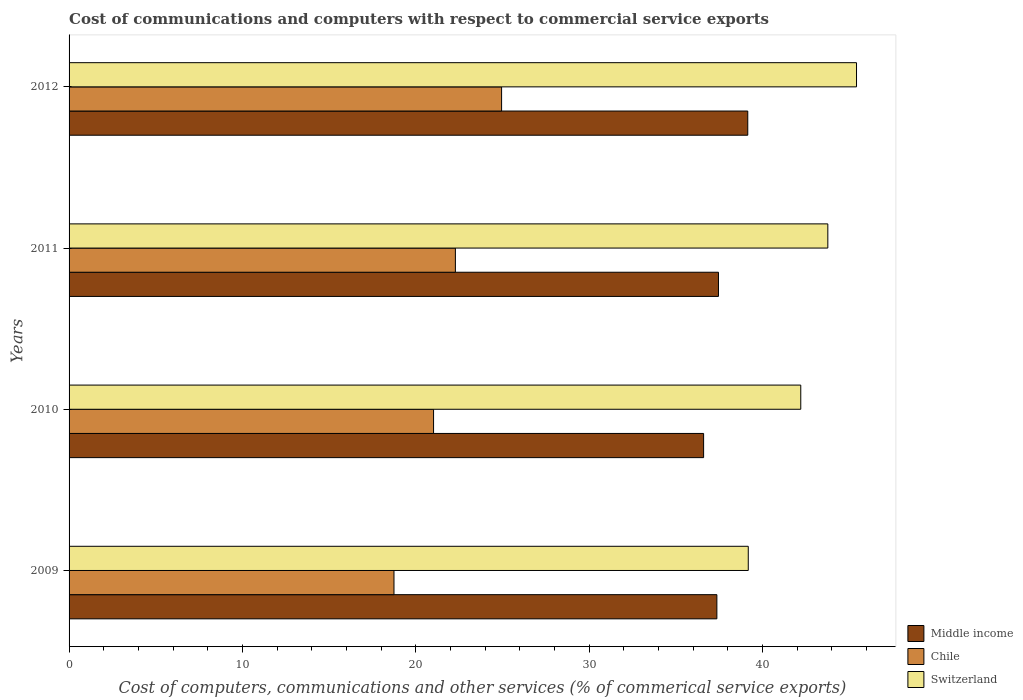How many groups of bars are there?
Your answer should be very brief. 4. Are the number of bars per tick equal to the number of legend labels?
Make the answer very short. Yes. Are the number of bars on each tick of the Y-axis equal?
Offer a very short reply. Yes. What is the label of the 2nd group of bars from the top?
Your answer should be very brief. 2011. In how many cases, is the number of bars for a given year not equal to the number of legend labels?
Make the answer very short. 0. What is the cost of communications and computers in Chile in 2010?
Offer a very short reply. 21.02. Across all years, what is the maximum cost of communications and computers in Chile?
Offer a very short reply. 24.95. Across all years, what is the minimum cost of communications and computers in Middle income?
Offer a terse response. 36.6. What is the total cost of communications and computers in Middle income in the graph?
Offer a terse response. 150.56. What is the difference between the cost of communications and computers in Chile in 2009 and that in 2012?
Your answer should be compact. -6.21. What is the difference between the cost of communications and computers in Switzerland in 2011 and the cost of communications and computers in Chile in 2012?
Make the answer very short. 18.82. What is the average cost of communications and computers in Chile per year?
Your answer should be compact. 21.75. In the year 2009, what is the difference between the cost of communications and computers in Chile and cost of communications and computers in Switzerland?
Ensure brevity in your answer.  -20.43. In how many years, is the cost of communications and computers in Switzerland greater than 44 %?
Offer a very short reply. 1. What is the ratio of the cost of communications and computers in Middle income in 2010 to that in 2012?
Your answer should be compact. 0.93. What is the difference between the highest and the second highest cost of communications and computers in Middle income?
Your answer should be compact. 1.69. What is the difference between the highest and the lowest cost of communications and computers in Switzerland?
Your answer should be compact. 6.24. What does the 2nd bar from the top in 2010 represents?
Your response must be concise. Chile. What does the 1st bar from the bottom in 2009 represents?
Give a very brief answer. Middle income. How many years are there in the graph?
Your response must be concise. 4. What is the difference between two consecutive major ticks on the X-axis?
Provide a succinct answer. 10. Does the graph contain grids?
Ensure brevity in your answer.  No. How many legend labels are there?
Ensure brevity in your answer.  3. How are the legend labels stacked?
Provide a succinct answer. Vertical. What is the title of the graph?
Your answer should be compact. Cost of communications and computers with respect to commercial service exports. Does "Estonia" appear as one of the legend labels in the graph?
Your answer should be very brief. No. What is the label or title of the X-axis?
Your answer should be compact. Cost of computers, communications and other services (% of commerical service exports). What is the label or title of the Y-axis?
Your answer should be very brief. Years. What is the Cost of computers, communications and other services (% of commerical service exports) in Middle income in 2009?
Give a very brief answer. 37.36. What is the Cost of computers, communications and other services (% of commerical service exports) in Chile in 2009?
Provide a short and direct response. 18.74. What is the Cost of computers, communications and other services (% of commerical service exports) of Switzerland in 2009?
Your response must be concise. 39.17. What is the Cost of computers, communications and other services (% of commerical service exports) of Middle income in 2010?
Your response must be concise. 36.6. What is the Cost of computers, communications and other services (% of commerical service exports) of Chile in 2010?
Offer a terse response. 21.02. What is the Cost of computers, communications and other services (% of commerical service exports) in Switzerland in 2010?
Your answer should be very brief. 42.2. What is the Cost of computers, communications and other services (% of commerical service exports) in Middle income in 2011?
Make the answer very short. 37.45. What is the Cost of computers, communications and other services (% of commerical service exports) in Chile in 2011?
Your answer should be very brief. 22.28. What is the Cost of computers, communications and other services (% of commerical service exports) of Switzerland in 2011?
Provide a short and direct response. 43.76. What is the Cost of computers, communications and other services (% of commerical service exports) of Middle income in 2012?
Offer a very short reply. 39.14. What is the Cost of computers, communications and other services (% of commerical service exports) of Chile in 2012?
Provide a succinct answer. 24.95. What is the Cost of computers, communications and other services (% of commerical service exports) of Switzerland in 2012?
Your response must be concise. 45.42. Across all years, what is the maximum Cost of computers, communications and other services (% of commerical service exports) of Middle income?
Keep it short and to the point. 39.14. Across all years, what is the maximum Cost of computers, communications and other services (% of commerical service exports) of Chile?
Your answer should be compact. 24.95. Across all years, what is the maximum Cost of computers, communications and other services (% of commerical service exports) in Switzerland?
Keep it short and to the point. 45.42. Across all years, what is the minimum Cost of computers, communications and other services (% of commerical service exports) in Middle income?
Ensure brevity in your answer.  36.6. Across all years, what is the minimum Cost of computers, communications and other services (% of commerical service exports) of Chile?
Your answer should be compact. 18.74. Across all years, what is the minimum Cost of computers, communications and other services (% of commerical service exports) of Switzerland?
Provide a short and direct response. 39.17. What is the total Cost of computers, communications and other services (% of commerical service exports) of Middle income in the graph?
Your answer should be compact. 150.56. What is the total Cost of computers, communications and other services (% of commerical service exports) of Chile in the graph?
Your answer should be compact. 86.99. What is the total Cost of computers, communications and other services (% of commerical service exports) in Switzerland in the graph?
Your response must be concise. 170.55. What is the difference between the Cost of computers, communications and other services (% of commerical service exports) of Middle income in 2009 and that in 2010?
Your response must be concise. 0.76. What is the difference between the Cost of computers, communications and other services (% of commerical service exports) in Chile in 2009 and that in 2010?
Offer a terse response. -2.28. What is the difference between the Cost of computers, communications and other services (% of commerical service exports) of Switzerland in 2009 and that in 2010?
Your answer should be very brief. -3.03. What is the difference between the Cost of computers, communications and other services (% of commerical service exports) of Middle income in 2009 and that in 2011?
Make the answer very short. -0.09. What is the difference between the Cost of computers, communications and other services (% of commerical service exports) in Chile in 2009 and that in 2011?
Your answer should be very brief. -3.54. What is the difference between the Cost of computers, communications and other services (% of commerical service exports) in Switzerland in 2009 and that in 2011?
Your response must be concise. -4.59. What is the difference between the Cost of computers, communications and other services (% of commerical service exports) in Middle income in 2009 and that in 2012?
Your response must be concise. -1.78. What is the difference between the Cost of computers, communications and other services (% of commerical service exports) of Chile in 2009 and that in 2012?
Provide a succinct answer. -6.21. What is the difference between the Cost of computers, communications and other services (% of commerical service exports) in Switzerland in 2009 and that in 2012?
Keep it short and to the point. -6.24. What is the difference between the Cost of computers, communications and other services (% of commerical service exports) in Middle income in 2010 and that in 2011?
Offer a terse response. -0.86. What is the difference between the Cost of computers, communications and other services (% of commerical service exports) of Chile in 2010 and that in 2011?
Your answer should be compact. -1.26. What is the difference between the Cost of computers, communications and other services (% of commerical service exports) of Switzerland in 2010 and that in 2011?
Your answer should be compact. -1.56. What is the difference between the Cost of computers, communications and other services (% of commerical service exports) in Middle income in 2010 and that in 2012?
Ensure brevity in your answer.  -2.55. What is the difference between the Cost of computers, communications and other services (% of commerical service exports) in Chile in 2010 and that in 2012?
Your response must be concise. -3.92. What is the difference between the Cost of computers, communications and other services (% of commerical service exports) in Switzerland in 2010 and that in 2012?
Your answer should be compact. -3.22. What is the difference between the Cost of computers, communications and other services (% of commerical service exports) of Middle income in 2011 and that in 2012?
Your answer should be compact. -1.69. What is the difference between the Cost of computers, communications and other services (% of commerical service exports) of Chile in 2011 and that in 2012?
Keep it short and to the point. -2.66. What is the difference between the Cost of computers, communications and other services (% of commerical service exports) of Switzerland in 2011 and that in 2012?
Provide a short and direct response. -1.65. What is the difference between the Cost of computers, communications and other services (% of commerical service exports) in Middle income in 2009 and the Cost of computers, communications and other services (% of commerical service exports) in Chile in 2010?
Provide a succinct answer. 16.34. What is the difference between the Cost of computers, communications and other services (% of commerical service exports) in Middle income in 2009 and the Cost of computers, communications and other services (% of commerical service exports) in Switzerland in 2010?
Offer a terse response. -4.84. What is the difference between the Cost of computers, communications and other services (% of commerical service exports) of Chile in 2009 and the Cost of computers, communications and other services (% of commerical service exports) of Switzerland in 2010?
Your answer should be very brief. -23.46. What is the difference between the Cost of computers, communications and other services (% of commerical service exports) of Middle income in 2009 and the Cost of computers, communications and other services (% of commerical service exports) of Chile in 2011?
Give a very brief answer. 15.08. What is the difference between the Cost of computers, communications and other services (% of commerical service exports) of Middle income in 2009 and the Cost of computers, communications and other services (% of commerical service exports) of Switzerland in 2011?
Offer a terse response. -6.4. What is the difference between the Cost of computers, communications and other services (% of commerical service exports) in Chile in 2009 and the Cost of computers, communications and other services (% of commerical service exports) in Switzerland in 2011?
Provide a succinct answer. -25.02. What is the difference between the Cost of computers, communications and other services (% of commerical service exports) in Middle income in 2009 and the Cost of computers, communications and other services (% of commerical service exports) in Chile in 2012?
Offer a very short reply. 12.42. What is the difference between the Cost of computers, communications and other services (% of commerical service exports) in Middle income in 2009 and the Cost of computers, communications and other services (% of commerical service exports) in Switzerland in 2012?
Offer a terse response. -8.05. What is the difference between the Cost of computers, communications and other services (% of commerical service exports) of Chile in 2009 and the Cost of computers, communications and other services (% of commerical service exports) of Switzerland in 2012?
Ensure brevity in your answer.  -26.68. What is the difference between the Cost of computers, communications and other services (% of commerical service exports) in Middle income in 2010 and the Cost of computers, communications and other services (% of commerical service exports) in Chile in 2011?
Offer a very short reply. 14.32. What is the difference between the Cost of computers, communications and other services (% of commerical service exports) in Middle income in 2010 and the Cost of computers, communications and other services (% of commerical service exports) in Switzerland in 2011?
Keep it short and to the point. -7.16. What is the difference between the Cost of computers, communications and other services (% of commerical service exports) in Chile in 2010 and the Cost of computers, communications and other services (% of commerical service exports) in Switzerland in 2011?
Provide a succinct answer. -22.74. What is the difference between the Cost of computers, communications and other services (% of commerical service exports) in Middle income in 2010 and the Cost of computers, communications and other services (% of commerical service exports) in Chile in 2012?
Your response must be concise. 11.65. What is the difference between the Cost of computers, communications and other services (% of commerical service exports) in Middle income in 2010 and the Cost of computers, communications and other services (% of commerical service exports) in Switzerland in 2012?
Your response must be concise. -8.82. What is the difference between the Cost of computers, communications and other services (% of commerical service exports) of Chile in 2010 and the Cost of computers, communications and other services (% of commerical service exports) of Switzerland in 2012?
Keep it short and to the point. -24.39. What is the difference between the Cost of computers, communications and other services (% of commerical service exports) of Middle income in 2011 and the Cost of computers, communications and other services (% of commerical service exports) of Chile in 2012?
Offer a very short reply. 12.51. What is the difference between the Cost of computers, communications and other services (% of commerical service exports) of Middle income in 2011 and the Cost of computers, communications and other services (% of commerical service exports) of Switzerland in 2012?
Offer a very short reply. -7.96. What is the difference between the Cost of computers, communications and other services (% of commerical service exports) of Chile in 2011 and the Cost of computers, communications and other services (% of commerical service exports) of Switzerland in 2012?
Provide a succinct answer. -23.13. What is the average Cost of computers, communications and other services (% of commerical service exports) in Middle income per year?
Make the answer very short. 37.64. What is the average Cost of computers, communications and other services (% of commerical service exports) in Chile per year?
Provide a short and direct response. 21.75. What is the average Cost of computers, communications and other services (% of commerical service exports) of Switzerland per year?
Offer a terse response. 42.64. In the year 2009, what is the difference between the Cost of computers, communications and other services (% of commerical service exports) in Middle income and Cost of computers, communications and other services (% of commerical service exports) in Chile?
Provide a short and direct response. 18.62. In the year 2009, what is the difference between the Cost of computers, communications and other services (% of commerical service exports) of Middle income and Cost of computers, communications and other services (% of commerical service exports) of Switzerland?
Give a very brief answer. -1.81. In the year 2009, what is the difference between the Cost of computers, communications and other services (% of commerical service exports) in Chile and Cost of computers, communications and other services (% of commerical service exports) in Switzerland?
Your response must be concise. -20.43. In the year 2010, what is the difference between the Cost of computers, communications and other services (% of commerical service exports) of Middle income and Cost of computers, communications and other services (% of commerical service exports) of Chile?
Give a very brief answer. 15.58. In the year 2010, what is the difference between the Cost of computers, communications and other services (% of commerical service exports) of Middle income and Cost of computers, communications and other services (% of commerical service exports) of Switzerland?
Your response must be concise. -5.6. In the year 2010, what is the difference between the Cost of computers, communications and other services (% of commerical service exports) in Chile and Cost of computers, communications and other services (% of commerical service exports) in Switzerland?
Give a very brief answer. -21.18. In the year 2011, what is the difference between the Cost of computers, communications and other services (% of commerical service exports) in Middle income and Cost of computers, communications and other services (% of commerical service exports) in Chile?
Offer a terse response. 15.17. In the year 2011, what is the difference between the Cost of computers, communications and other services (% of commerical service exports) of Middle income and Cost of computers, communications and other services (% of commerical service exports) of Switzerland?
Your response must be concise. -6.31. In the year 2011, what is the difference between the Cost of computers, communications and other services (% of commerical service exports) in Chile and Cost of computers, communications and other services (% of commerical service exports) in Switzerland?
Give a very brief answer. -21.48. In the year 2012, what is the difference between the Cost of computers, communications and other services (% of commerical service exports) of Middle income and Cost of computers, communications and other services (% of commerical service exports) of Chile?
Provide a succinct answer. 14.2. In the year 2012, what is the difference between the Cost of computers, communications and other services (% of commerical service exports) of Middle income and Cost of computers, communications and other services (% of commerical service exports) of Switzerland?
Your answer should be very brief. -6.27. In the year 2012, what is the difference between the Cost of computers, communications and other services (% of commerical service exports) in Chile and Cost of computers, communications and other services (% of commerical service exports) in Switzerland?
Keep it short and to the point. -20.47. What is the ratio of the Cost of computers, communications and other services (% of commerical service exports) of Middle income in 2009 to that in 2010?
Offer a terse response. 1.02. What is the ratio of the Cost of computers, communications and other services (% of commerical service exports) of Chile in 2009 to that in 2010?
Provide a short and direct response. 0.89. What is the ratio of the Cost of computers, communications and other services (% of commerical service exports) of Switzerland in 2009 to that in 2010?
Give a very brief answer. 0.93. What is the ratio of the Cost of computers, communications and other services (% of commerical service exports) in Chile in 2009 to that in 2011?
Your answer should be very brief. 0.84. What is the ratio of the Cost of computers, communications and other services (% of commerical service exports) in Switzerland in 2009 to that in 2011?
Give a very brief answer. 0.9. What is the ratio of the Cost of computers, communications and other services (% of commerical service exports) of Middle income in 2009 to that in 2012?
Your response must be concise. 0.95. What is the ratio of the Cost of computers, communications and other services (% of commerical service exports) in Chile in 2009 to that in 2012?
Offer a terse response. 0.75. What is the ratio of the Cost of computers, communications and other services (% of commerical service exports) in Switzerland in 2009 to that in 2012?
Your answer should be compact. 0.86. What is the ratio of the Cost of computers, communications and other services (% of commerical service exports) of Middle income in 2010 to that in 2011?
Offer a terse response. 0.98. What is the ratio of the Cost of computers, communications and other services (% of commerical service exports) of Chile in 2010 to that in 2011?
Ensure brevity in your answer.  0.94. What is the ratio of the Cost of computers, communications and other services (% of commerical service exports) of Middle income in 2010 to that in 2012?
Offer a very short reply. 0.93. What is the ratio of the Cost of computers, communications and other services (% of commerical service exports) of Chile in 2010 to that in 2012?
Offer a terse response. 0.84. What is the ratio of the Cost of computers, communications and other services (% of commerical service exports) in Switzerland in 2010 to that in 2012?
Provide a short and direct response. 0.93. What is the ratio of the Cost of computers, communications and other services (% of commerical service exports) in Middle income in 2011 to that in 2012?
Your answer should be compact. 0.96. What is the ratio of the Cost of computers, communications and other services (% of commerical service exports) of Chile in 2011 to that in 2012?
Keep it short and to the point. 0.89. What is the ratio of the Cost of computers, communications and other services (% of commerical service exports) of Switzerland in 2011 to that in 2012?
Offer a very short reply. 0.96. What is the difference between the highest and the second highest Cost of computers, communications and other services (% of commerical service exports) of Middle income?
Ensure brevity in your answer.  1.69. What is the difference between the highest and the second highest Cost of computers, communications and other services (% of commerical service exports) in Chile?
Give a very brief answer. 2.66. What is the difference between the highest and the second highest Cost of computers, communications and other services (% of commerical service exports) in Switzerland?
Offer a terse response. 1.65. What is the difference between the highest and the lowest Cost of computers, communications and other services (% of commerical service exports) in Middle income?
Keep it short and to the point. 2.55. What is the difference between the highest and the lowest Cost of computers, communications and other services (% of commerical service exports) in Chile?
Give a very brief answer. 6.21. What is the difference between the highest and the lowest Cost of computers, communications and other services (% of commerical service exports) in Switzerland?
Make the answer very short. 6.24. 